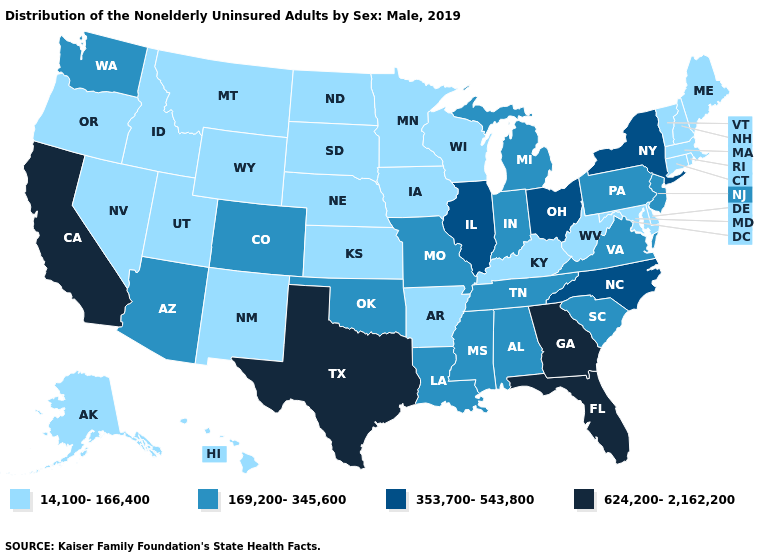What is the value of Arkansas?
Keep it brief. 14,100-166,400. Which states hav the highest value in the West?
Concise answer only. California. Does California have the highest value in the West?
Quick response, please. Yes. Does Oklahoma have a higher value than Hawaii?
Be succinct. Yes. Does Massachusetts have the lowest value in the Northeast?
Quick response, please. Yes. Which states have the lowest value in the South?
Give a very brief answer. Arkansas, Delaware, Kentucky, Maryland, West Virginia. Name the states that have a value in the range 624,200-2,162,200?
Quick response, please. California, Florida, Georgia, Texas. What is the highest value in the USA?
Answer briefly. 624,200-2,162,200. Does Iowa have a higher value than Montana?
Concise answer only. No. Name the states that have a value in the range 14,100-166,400?
Concise answer only. Alaska, Arkansas, Connecticut, Delaware, Hawaii, Idaho, Iowa, Kansas, Kentucky, Maine, Maryland, Massachusetts, Minnesota, Montana, Nebraska, Nevada, New Hampshire, New Mexico, North Dakota, Oregon, Rhode Island, South Dakota, Utah, Vermont, West Virginia, Wisconsin, Wyoming. Name the states that have a value in the range 14,100-166,400?
Quick response, please. Alaska, Arkansas, Connecticut, Delaware, Hawaii, Idaho, Iowa, Kansas, Kentucky, Maine, Maryland, Massachusetts, Minnesota, Montana, Nebraska, Nevada, New Hampshire, New Mexico, North Dakota, Oregon, Rhode Island, South Dakota, Utah, Vermont, West Virginia, Wisconsin, Wyoming. What is the value of Idaho?
Give a very brief answer. 14,100-166,400. What is the lowest value in the South?
Give a very brief answer. 14,100-166,400. Does Tennessee have the lowest value in the USA?
Keep it brief. No. Among the states that border West Virginia , does Kentucky have the highest value?
Give a very brief answer. No. 